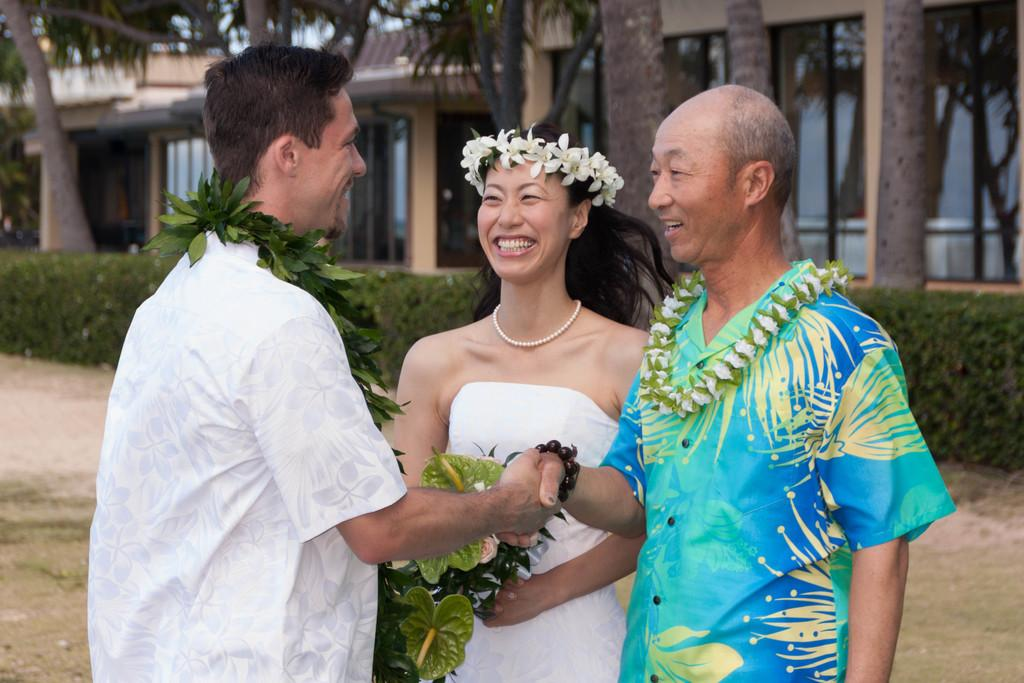How many people are in the image? There are three people in the image. What decorations can be seen in the image? Garlands and flower crowns are present in the image. What is the facial expression of the people in the image? The people in the image are smiling. What position are the people in the image? The people in the image are standing. What can be seen in the background of the image? There are plants, buildings, and trees in the background of the image. What type of punishment is being administered to the people in the image? There is no punishment being administered to the people in the image; they are smiling and wearing flower crowns. What material is the brass used for in the image? There is no brass present in the image. 